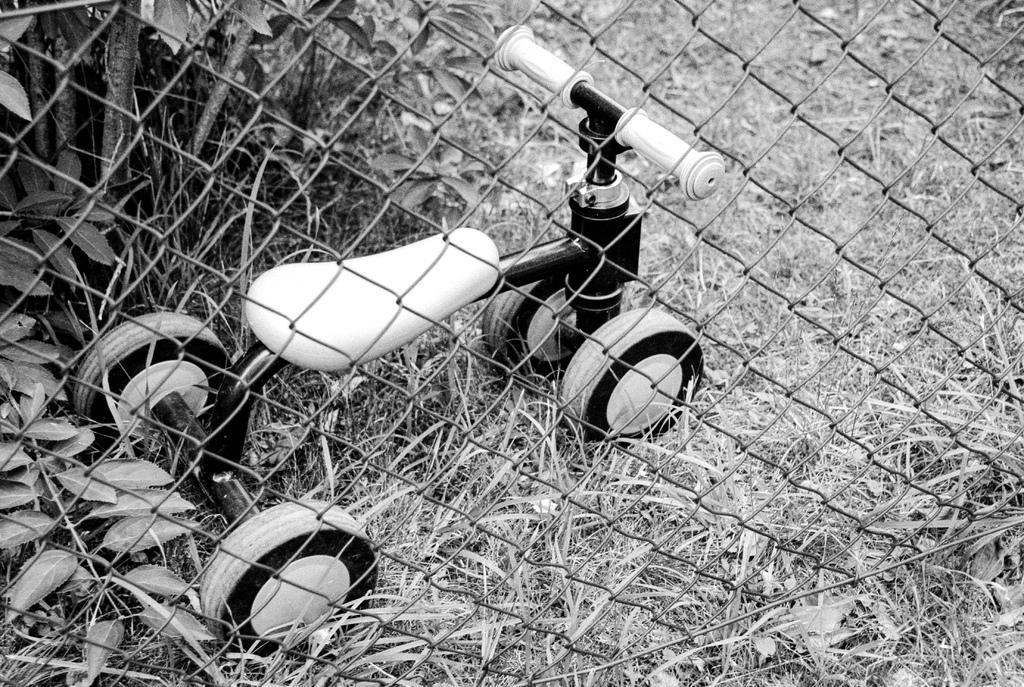What is the color scheme of the image? The image is black and white. What type of vehicle can be seen in the image? There is a mini vehicle in the image that resembles a bicycle. What type of vegetation is visible in the image? There are plants visible in the image. What type of ground surface is present in the image? There is grass on the ground in the image. What type of barrier is present in the image? There is a fence in the image. What type of snail can be seen crawling on the fence in the image? There are no snails present in the image; it only features a mini vehicle, plants, grass, and a fence. What type of drawer can be seen in the image? There are no drawers present in the image. 